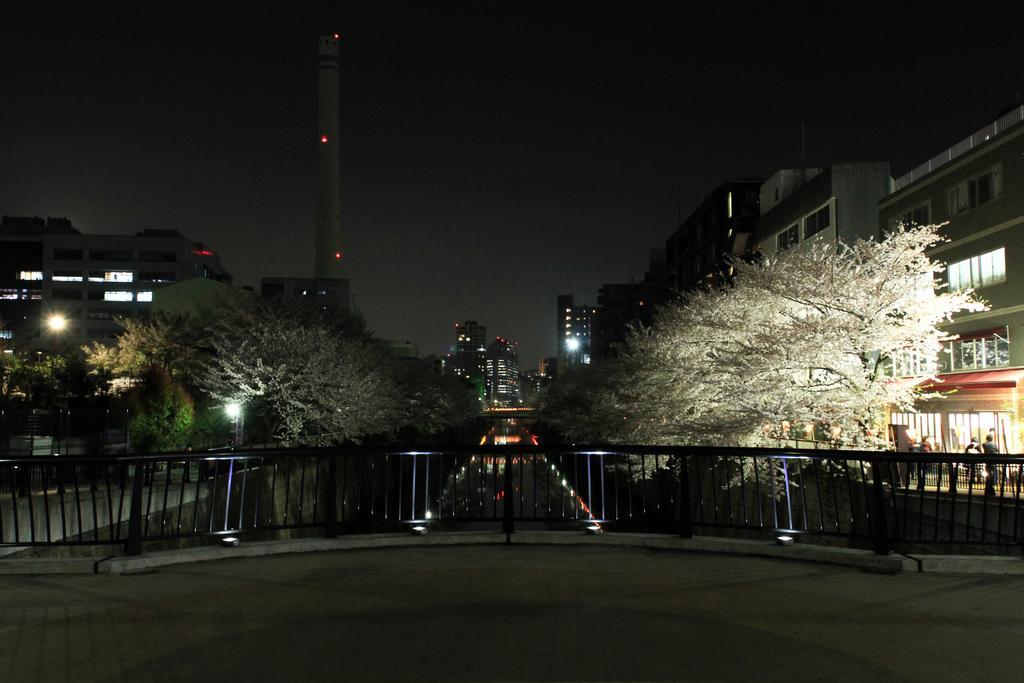Can you describe this image briefly? In this image I can see buildings , fence ,lake , lights and trees visible in the middle ,at the top I can see the sky , in front of the building I can see persons and this picture is taken in night view. 